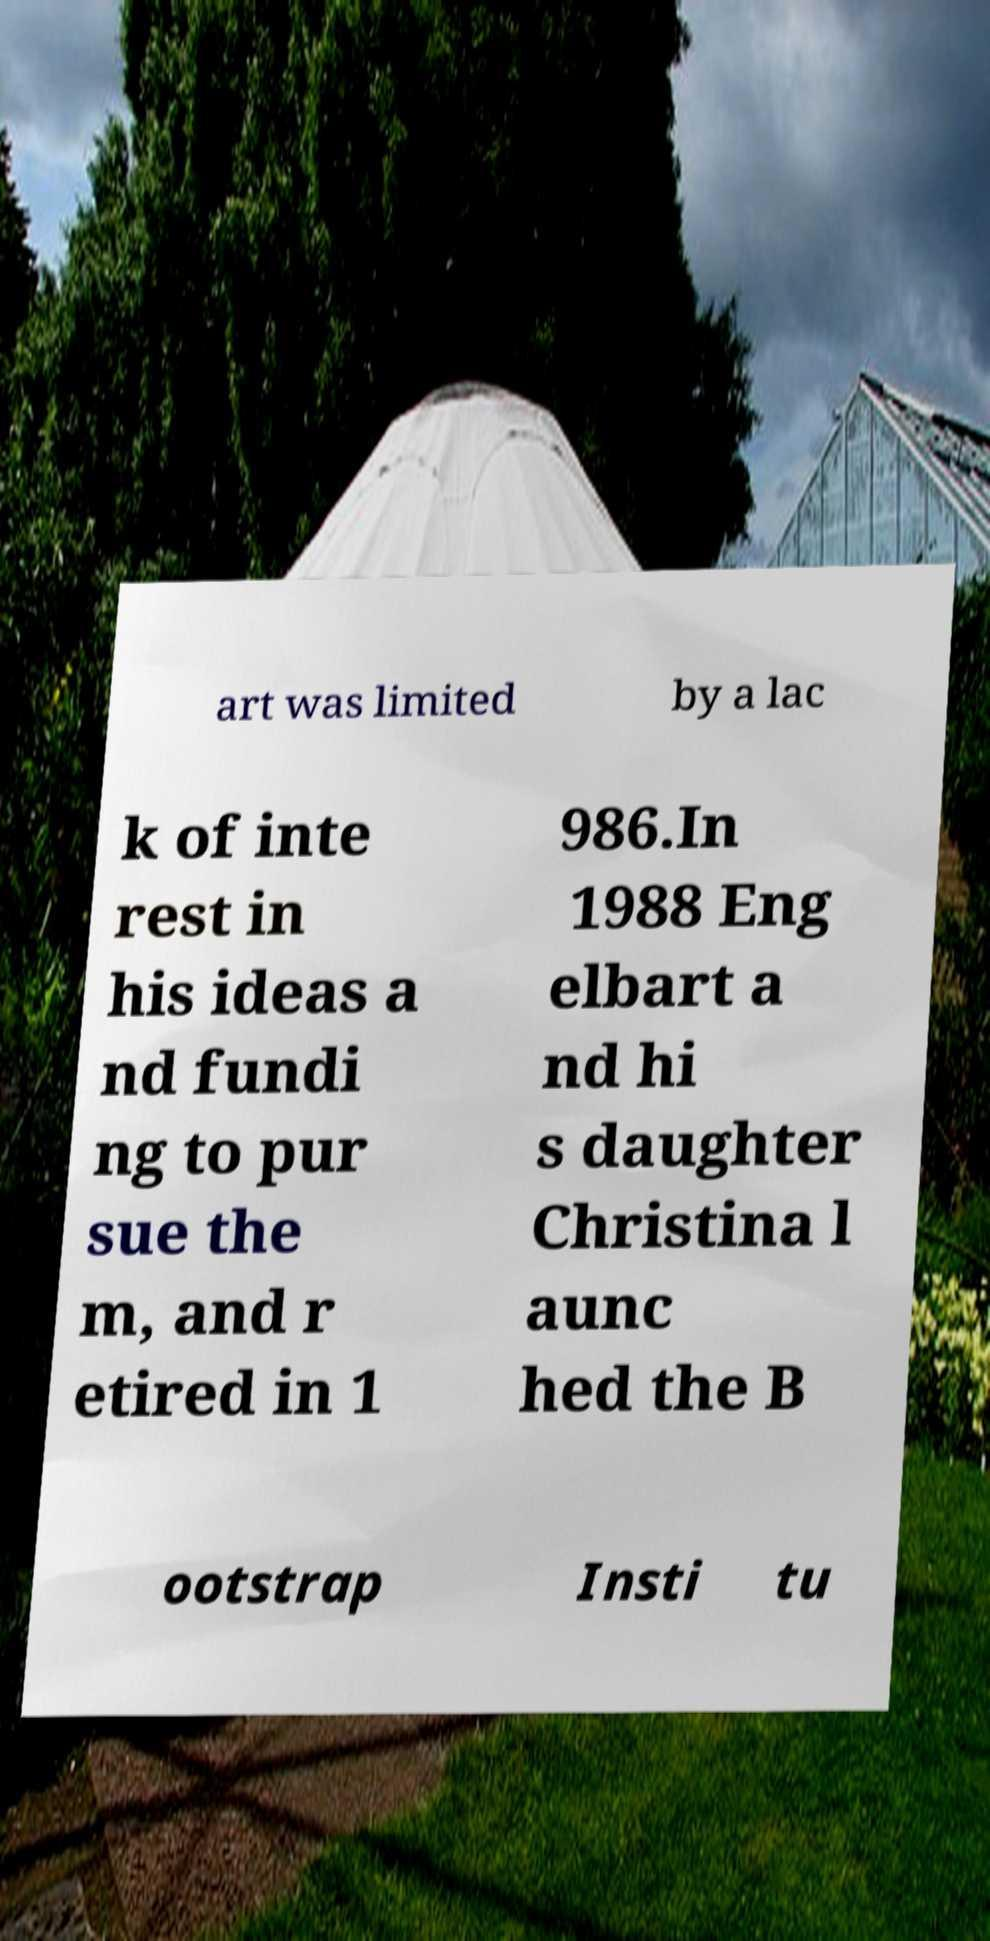Could you assist in decoding the text presented in this image and type it out clearly? art was limited by a lac k of inte rest in his ideas a nd fundi ng to pur sue the m, and r etired in 1 986.In 1988 Eng elbart a nd hi s daughter Christina l aunc hed the B ootstrap Insti tu 